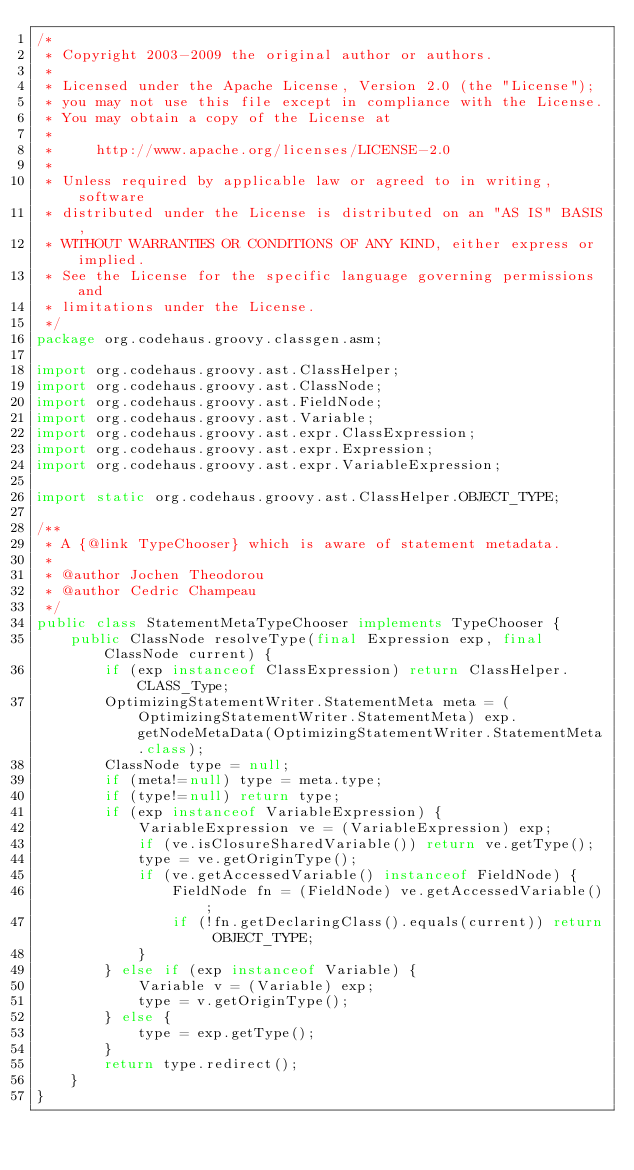Convert code to text. <code><loc_0><loc_0><loc_500><loc_500><_Java_>/*
 * Copyright 2003-2009 the original author or authors.
 *
 * Licensed under the Apache License, Version 2.0 (the "License");
 * you may not use this file except in compliance with the License.
 * You may obtain a copy of the License at
 *
 *     http://www.apache.org/licenses/LICENSE-2.0
 *
 * Unless required by applicable law or agreed to in writing, software
 * distributed under the License is distributed on an "AS IS" BASIS,
 * WITHOUT WARRANTIES OR CONDITIONS OF ANY KIND, either express or implied.
 * See the License for the specific language governing permissions and
 * limitations under the License.
 */
package org.codehaus.groovy.classgen.asm;

import org.codehaus.groovy.ast.ClassHelper;
import org.codehaus.groovy.ast.ClassNode;
import org.codehaus.groovy.ast.FieldNode;
import org.codehaus.groovy.ast.Variable;
import org.codehaus.groovy.ast.expr.ClassExpression;
import org.codehaus.groovy.ast.expr.Expression;
import org.codehaus.groovy.ast.expr.VariableExpression;

import static org.codehaus.groovy.ast.ClassHelper.OBJECT_TYPE;

/**
 * A {@link TypeChooser} which is aware of statement metadata.
 *
 * @author Jochen Theodorou
 * @author Cedric Champeau
 */
public class StatementMetaTypeChooser implements TypeChooser {
    public ClassNode resolveType(final Expression exp, final ClassNode current) {
        if (exp instanceof ClassExpression) return ClassHelper.CLASS_Type;
        OptimizingStatementWriter.StatementMeta meta = (OptimizingStatementWriter.StatementMeta) exp.getNodeMetaData(OptimizingStatementWriter.StatementMeta.class);
        ClassNode type = null;
        if (meta!=null) type = meta.type;
        if (type!=null) return type;
        if (exp instanceof VariableExpression) {
            VariableExpression ve = (VariableExpression) exp;
            if (ve.isClosureSharedVariable()) return ve.getType();
            type = ve.getOriginType();
            if (ve.getAccessedVariable() instanceof FieldNode) {
                FieldNode fn = (FieldNode) ve.getAccessedVariable();
                if (!fn.getDeclaringClass().equals(current)) return OBJECT_TYPE;
            }
        } else if (exp instanceof Variable) {
            Variable v = (Variable) exp;
            type = v.getOriginType();
        } else {
            type = exp.getType();
        }
        return type.redirect();
    }
}
</code> 